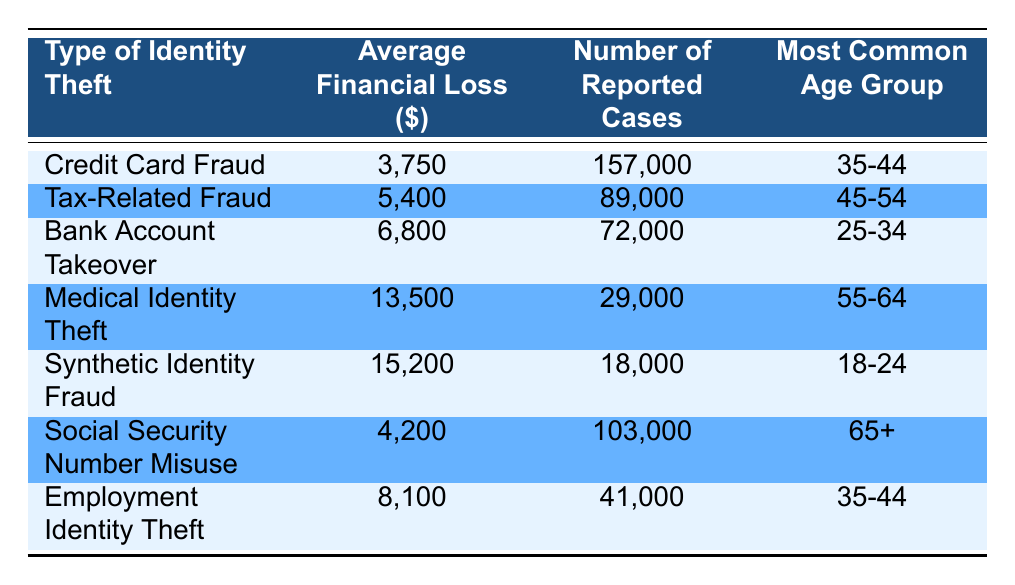What is the average financial loss for Medical Identity Theft? The table shows that the average financial loss for Medical Identity Theft is listed directly under the corresponding category. It indicates $13,500 as the average financial loss.
Answer: 13,500 Which type of identity theft has the highest average financial loss? By examining the average financial loss column, Synthetic Identity Fraud shows the highest value at $15,200, meaning it has the highest average loss among the listed incidents.
Answer: Synthetic Identity Fraud How many cases of Tax-Related Fraud were reported? The number of reported cases for Tax-Related Fraud is directly listed in the table, which indicates a total of 89,000 cases were reported.
Answer: 89,000 Is it true that Social Security Number Misuse has more reported cases than Medical Identity Theft? Looking at the number of reported cases, Social Security Number Misuse has 103,000 cases while Medical Identity Theft has only 29,000 reported cases. Therefore, it is true that Social Security Number Misuse has more reported cases.
Answer: Yes What is the average financial loss difference between Bank Account Takeover and Employment Identity Theft? The average financial loss for Bank Account Takeover is $6,800, and for Employment Identity Theft, it's $8,100. The difference is calculated as $8,100 - $6,800, which equals $1,300.
Answer: 1,300 Which age group is most commonly affected by Credit Card Fraud? The table lists the most common age group for Credit Card Fraud directly in the corresponding row, indicating that it is the 35 to 44 age group.
Answer: 35-44 What is the average financial loss for the age group 65 and over? For the age group 65 and over, the related type of identity theft is Social Security Number Misuse, which has an average financial loss of $4,200 as noted in the table.
Answer: 4,200 How many identity theft types have an average financial loss greater than $8,000? By reviewing the average financial loss for each identity theft type, we see that Medical Identity Theft ($13,500), Synthetic Identity Fraud ($15,200), and Employment Identity Theft ($8,100) have losses greater than $8,000. In total, there are three types.
Answer: 3 What is the total number of reported cases for all types of identity theft listed? The total number of reported cases can be calculated by adding each reported cases number together: 157,000 + 89,000 + 72,000 + 29,000 + 18,000 + 103,000 + 41,000 = 509,000.
Answer: 509,000 